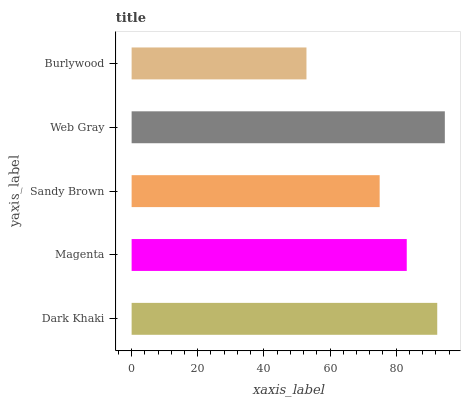Is Burlywood the minimum?
Answer yes or no. Yes. Is Web Gray the maximum?
Answer yes or no. Yes. Is Magenta the minimum?
Answer yes or no. No. Is Magenta the maximum?
Answer yes or no. No. Is Dark Khaki greater than Magenta?
Answer yes or no. Yes. Is Magenta less than Dark Khaki?
Answer yes or no. Yes. Is Magenta greater than Dark Khaki?
Answer yes or no. No. Is Dark Khaki less than Magenta?
Answer yes or no. No. Is Magenta the high median?
Answer yes or no. Yes. Is Magenta the low median?
Answer yes or no. Yes. Is Sandy Brown the high median?
Answer yes or no. No. Is Sandy Brown the low median?
Answer yes or no. No. 